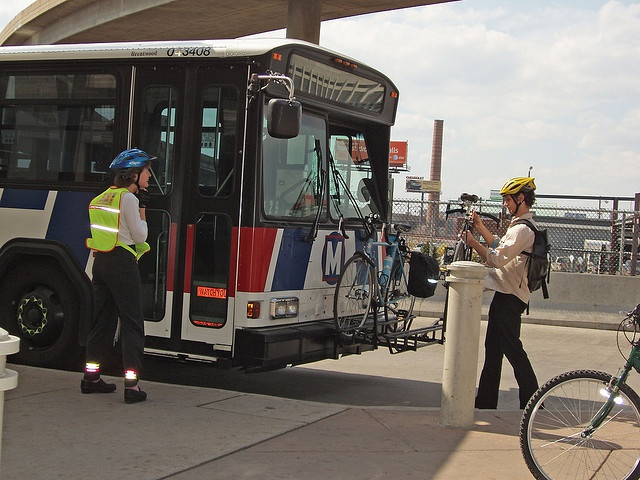Describe the objects in this image and their specific colors. I can see bus in white, black, gray, darkgray, and maroon tones, bicycle in white, gray, tan, and black tones, people in white, black, olive, and darkgray tones, people in white, black, and gray tones, and bicycle in white, black, gray, and darkgray tones in this image. 